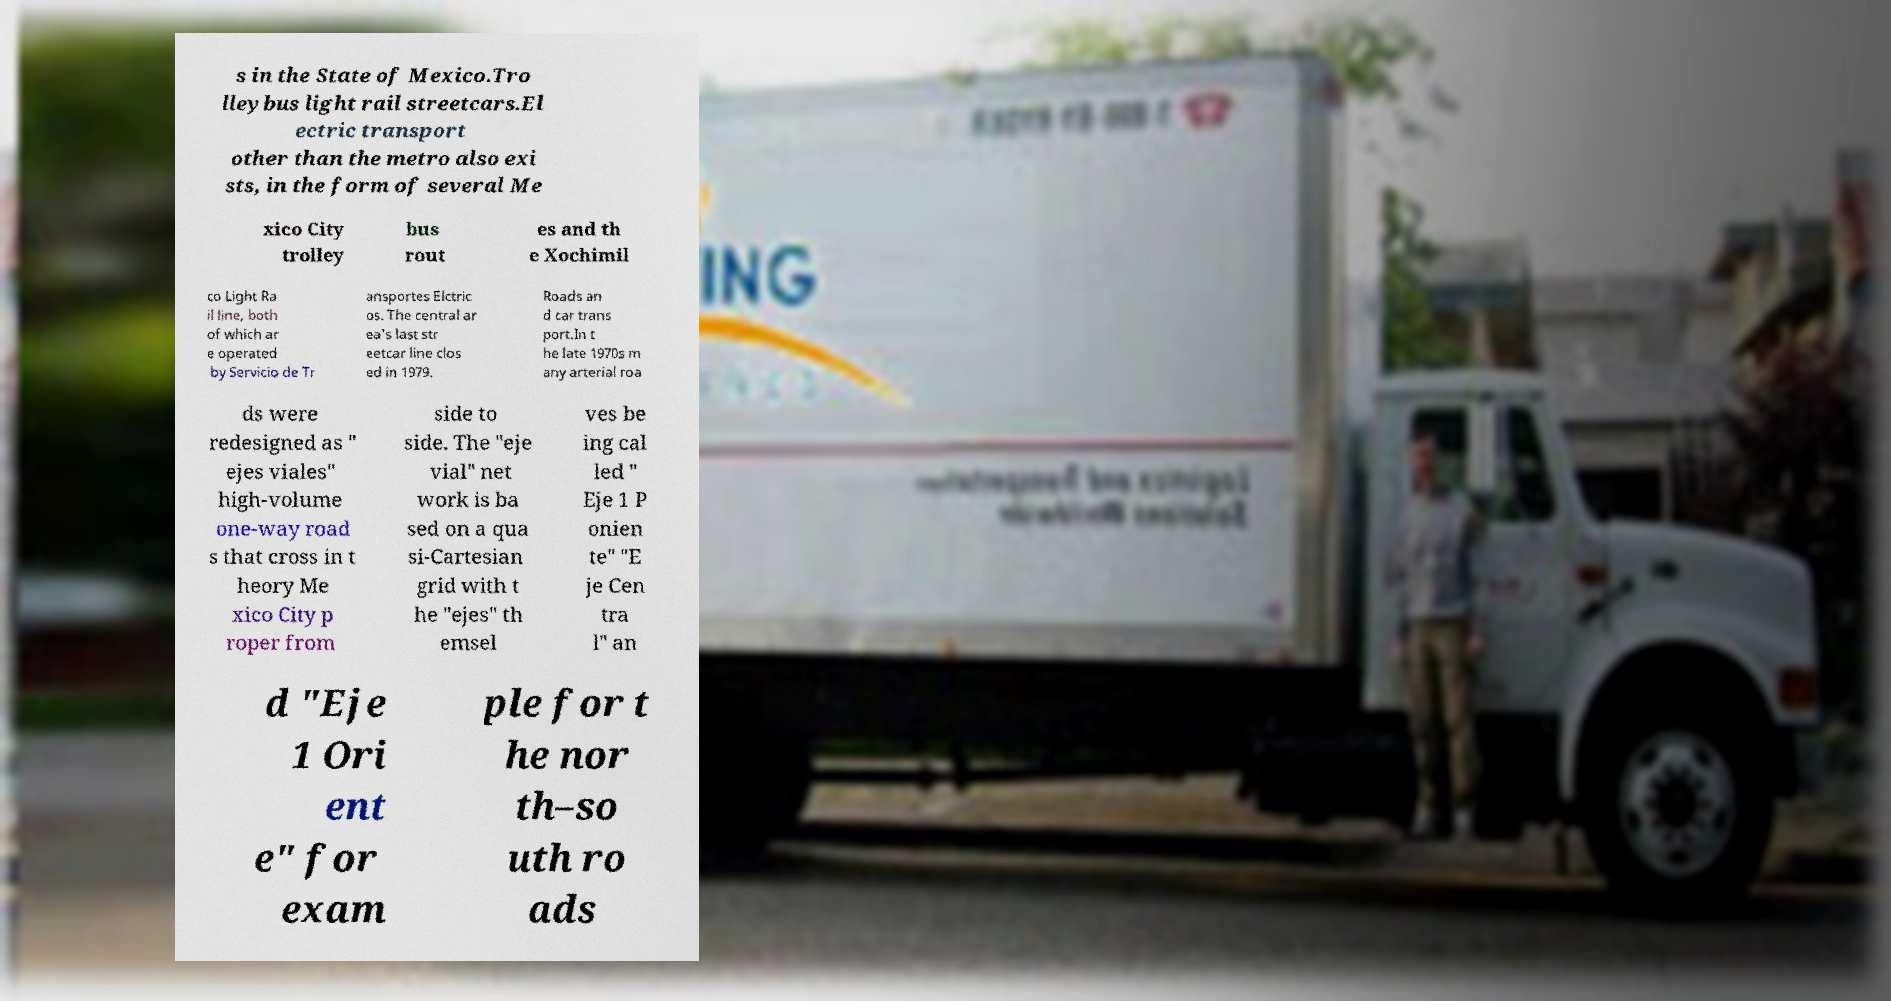Can you read and provide the text displayed in the image?This photo seems to have some interesting text. Can you extract and type it out for me? s in the State of Mexico.Tro lleybus light rail streetcars.El ectric transport other than the metro also exi sts, in the form of several Me xico City trolley bus rout es and th e Xochimil co Light Ra il line, both of which ar e operated by Servicio de Tr ansportes Elctric os. The central ar ea's last str eetcar line clos ed in 1979. Roads an d car trans port.In t he late 1970s m any arterial roa ds were redesigned as " ejes viales" high-volume one-way road s that cross in t heory Me xico City p roper from side to side. The "eje vial" net work is ba sed on a qua si-Cartesian grid with t he "ejes" th emsel ves be ing cal led " Eje 1 P onien te" "E je Cen tra l" an d "Eje 1 Ori ent e" for exam ple for t he nor th–so uth ro ads 